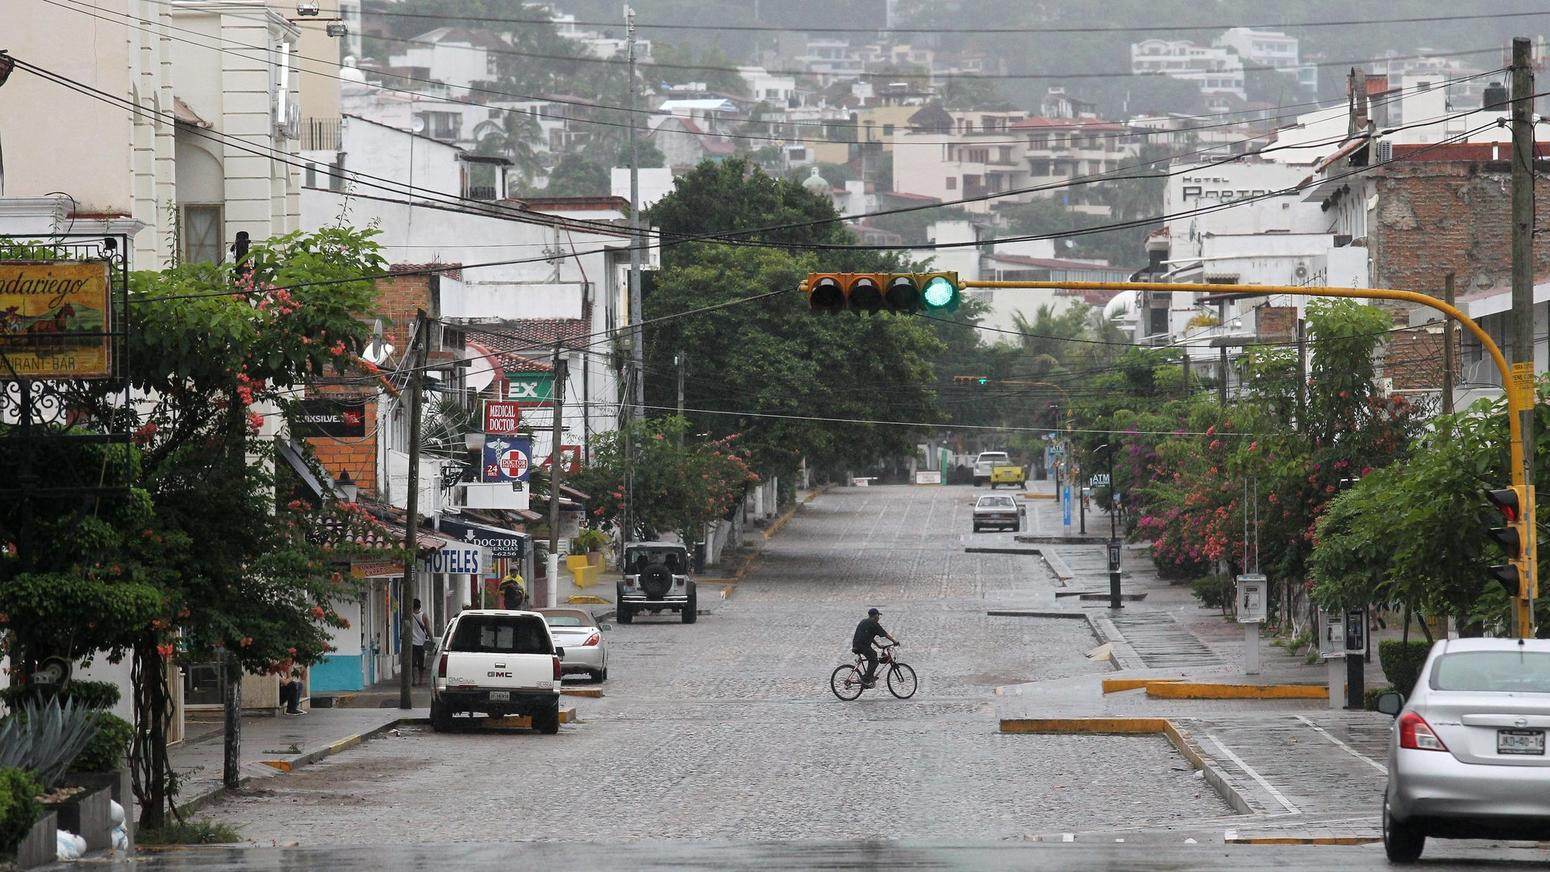What environmental or urban planning considerations can be observed in this street scene that impact the resident's quality of life? Visible urban planning elements include the well-maintained sidewalks and the presence of pedestrian crossings, which point to a pedestrian-friendly environment. The street's wide lanes suggest accommodation for various types of vehicles, potentially easing traffic flow. Moreover, abundant greenery can be seen even in this small section of the street, which could contribute to pleasant aesthetics and possibly aid in urban cooling and air purification, enhancing the quality of life for the residents. The intersection's traffic lights are also well-positioned to manage the flow of both vehicles and pedestrians safely. 